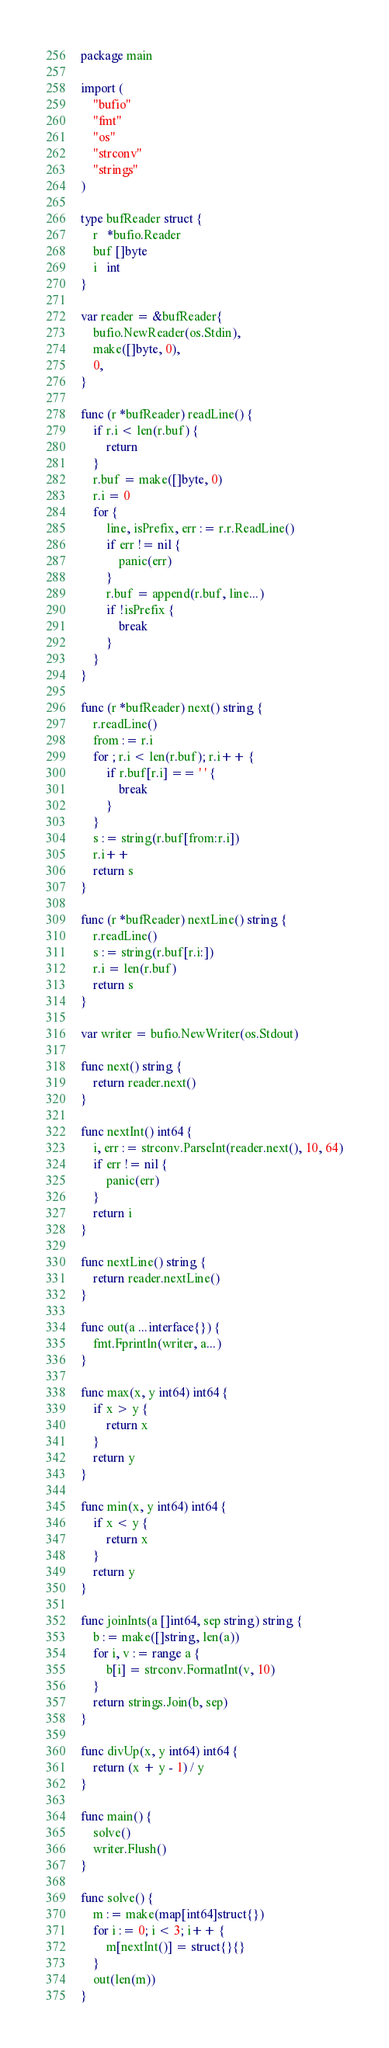Convert code to text. <code><loc_0><loc_0><loc_500><loc_500><_Go_>package main

import (
	"bufio"
	"fmt"
	"os"
	"strconv"
	"strings"
)

type bufReader struct {
	r   *bufio.Reader
	buf []byte
	i   int
}

var reader = &bufReader{
	bufio.NewReader(os.Stdin),
	make([]byte, 0),
	0,
}

func (r *bufReader) readLine() {
	if r.i < len(r.buf) {
		return
	}
	r.buf = make([]byte, 0)
	r.i = 0
	for {
		line, isPrefix, err := r.r.ReadLine()
		if err != nil {
			panic(err)
		}
		r.buf = append(r.buf, line...)
		if !isPrefix {
			break
		}
	}
}

func (r *bufReader) next() string {
	r.readLine()
	from := r.i
	for ; r.i < len(r.buf); r.i++ {
		if r.buf[r.i] == ' ' {
			break
		}
	}
	s := string(r.buf[from:r.i])
	r.i++
	return s
}

func (r *bufReader) nextLine() string {
	r.readLine()
	s := string(r.buf[r.i:])
	r.i = len(r.buf)
	return s
}

var writer = bufio.NewWriter(os.Stdout)

func next() string {
	return reader.next()
}

func nextInt() int64 {
	i, err := strconv.ParseInt(reader.next(), 10, 64)
	if err != nil {
		panic(err)
	}
	return i
}

func nextLine() string {
	return reader.nextLine()
}

func out(a ...interface{}) {
	fmt.Fprintln(writer, a...)
}

func max(x, y int64) int64 {
	if x > y {
		return x
	}
	return y
}

func min(x, y int64) int64 {
	if x < y {
		return x
	}
	return y
}

func joinInts(a []int64, sep string) string {
	b := make([]string, len(a))
	for i, v := range a {
		b[i] = strconv.FormatInt(v, 10)
	}
	return strings.Join(b, sep)
}

func divUp(x, y int64) int64 {
	return (x + y - 1) / y
}

func main() {
	solve()
	writer.Flush()
}

func solve() {
	m := make(map[int64]struct{})
	for i := 0; i < 3; i++ {
		m[nextInt()] = struct{}{}
	}
	out(len(m))
}
</code> 